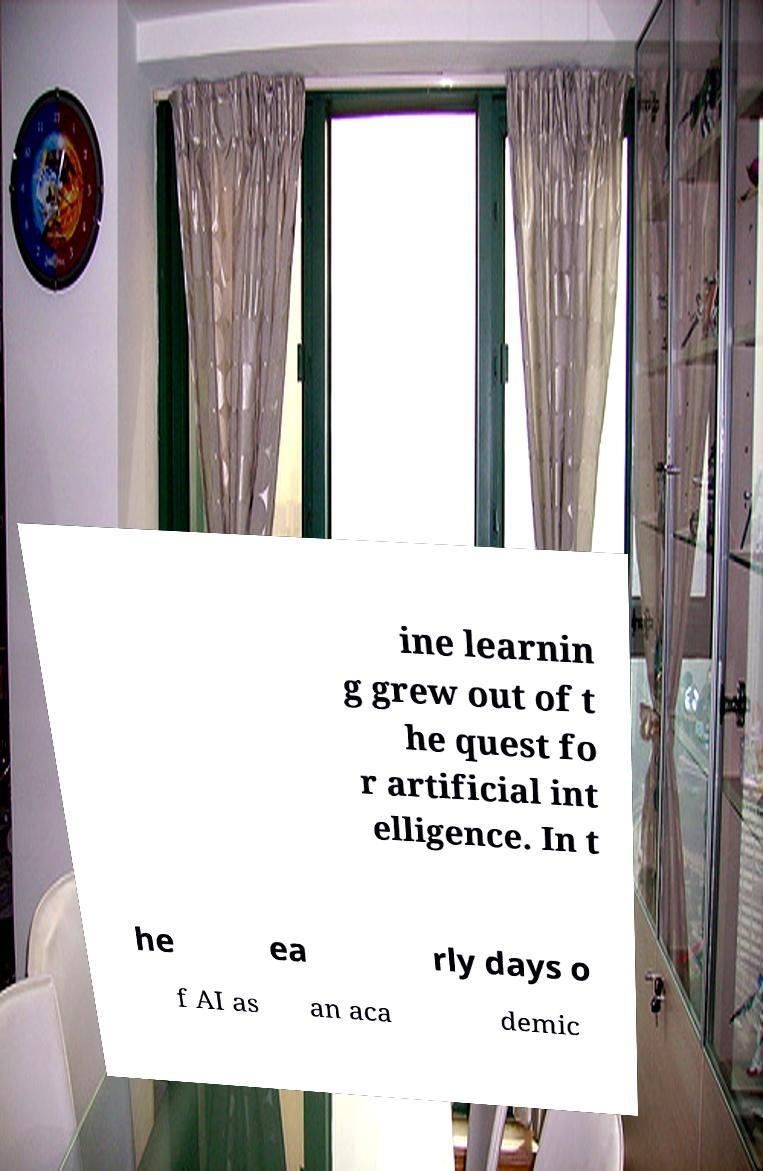There's text embedded in this image that I need extracted. Can you transcribe it verbatim? ine learnin g grew out of t he quest fo r artificial int elligence. In t he ea rly days o f AI as an aca demic 